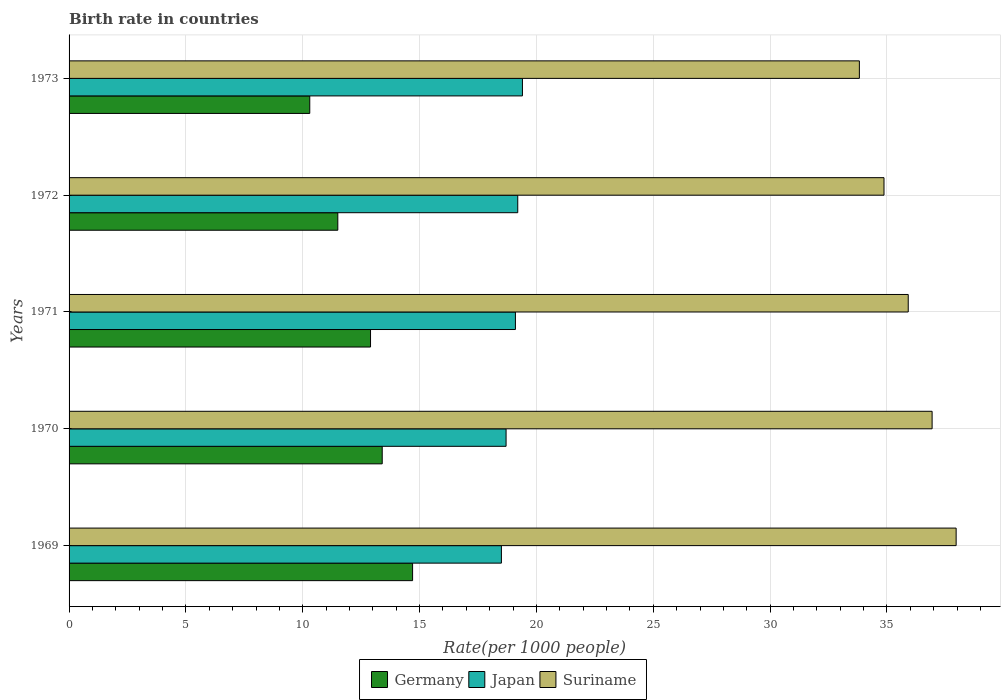How many bars are there on the 4th tick from the top?
Offer a very short reply. 3. What is the label of the 3rd group of bars from the top?
Keep it short and to the point. 1971. Across all years, what is the minimum birth rate in Germany?
Your answer should be very brief. 10.3. In which year was the birth rate in Germany maximum?
Your answer should be compact. 1969. In which year was the birth rate in Japan minimum?
Make the answer very short. 1969. What is the total birth rate in Japan in the graph?
Give a very brief answer. 94.9. What is the difference between the birth rate in Germany in 1971 and that in 1973?
Your answer should be very brief. 2.6. What is the difference between the birth rate in Suriname in 1970 and the birth rate in Germany in 1973?
Offer a very short reply. 26.63. What is the average birth rate in Suriname per year?
Your answer should be compact. 35.9. In the year 1970, what is the difference between the birth rate in Germany and birth rate in Suriname?
Give a very brief answer. -23.53. What is the ratio of the birth rate in Japan in 1970 to that in 1973?
Your response must be concise. 0.96. Is the difference between the birth rate in Germany in 1969 and 1971 greater than the difference between the birth rate in Suriname in 1969 and 1971?
Your response must be concise. No. What is the difference between the highest and the second highest birth rate in Suriname?
Your response must be concise. 1.03. What is the difference between the highest and the lowest birth rate in Suriname?
Ensure brevity in your answer.  4.14. In how many years, is the birth rate in Suriname greater than the average birth rate in Suriname taken over all years?
Offer a very short reply. 3. Is the sum of the birth rate in Japan in 1969 and 1972 greater than the maximum birth rate in Suriname across all years?
Give a very brief answer. No. What does the 2nd bar from the top in 1970 represents?
Ensure brevity in your answer.  Japan. What does the 3rd bar from the bottom in 1971 represents?
Ensure brevity in your answer.  Suriname. How many bars are there?
Offer a terse response. 15. What is the difference between two consecutive major ticks on the X-axis?
Your response must be concise. 5. Does the graph contain any zero values?
Your answer should be very brief. No. Does the graph contain grids?
Provide a short and direct response. Yes. What is the title of the graph?
Provide a short and direct response. Birth rate in countries. What is the label or title of the X-axis?
Ensure brevity in your answer.  Rate(per 1000 people). What is the label or title of the Y-axis?
Your answer should be very brief. Years. What is the Rate(per 1000 people) in Germany in 1969?
Provide a succinct answer. 14.7. What is the Rate(per 1000 people) of Japan in 1969?
Provide a short and direct response. 18.5. What is the Rate(per 1000 people) in Suriname in 1969?
Provide a short and direct response. 37.96. What is the Rate(per 1000 people) of Germany in 1970?
Your response must be concise. 13.4. What is the Rate(per 1000 people) of Japan in 1970?
Your response must be concise. 18.7. What is the Rate(per 1000 people) in Suriname in 1970?
Keep it short and to the point. 36.93. What is the Rate(per 1000 people) in Germany in 1971?
Provide a short and direct response. 12.9. What is the Rate(per 1000 people) in Japan in 1971?
Offer a terse response. 19.1. What is the Rate(per 1000 people) of Suriname in 1971?
Your answer should be compact. 35.91. What is the Rate(per 1000 people) of Japan in 1972?
Your response must be concise. 19.2. What is the Rate(per 1000 people) of Suriname in 1972?
Provide a short and direct response. 34.87. What is the Rate(per 1000 people) in Germany in 1973?
Provide a short and direct response. 10.3. What is the Rate(per 1000 people) of Suriname in 1973?
Keep it short and to the point. 33.82. Across all years, what is the maximum Rate(per 1000 people) of Germany?
Make the answer very short. 14.7. Across all years, what is the maximum Rate(per 1000 people) of Japan?
Your response must be concise. 19.4. Across all years, what is the maximum Rate(per 1000 people) in Suriname?
Your response must be concise. 37.96. Across all years, what is the minimum Rate(per 1000 people) of Germany?
Keep it short and to the point. 10.3. Across all years, what is the minimum Rate(per 1000 people) of Japan?
Your response must be concise. 18.5. Across all years, what is the minimum Rate(per 1000 people) of Suriname?
Provide a short and direct response. 33.82. What is the total Rate(per 1000 people) in Germany in the graph?
Your answer should be compact. 62.8. What is the total Rate(per 1000 people) in Japan in the graph?
Your answer should be very brief. 94.9. What is the total Rate(per 1000 people) of Suriname in the graph?
Your answer should be very brief. 179.49. What is the difference between the Rate(per 1000 people) of Germany in 1969 and that in 1970?
Ensure brevity in your answer.  1.3. What is the difference between the Rate(per 1000 people) of Japan in 1969 and that in 1970?
Provide a short and direct response. -0.2. What is the difference between the Rate(per 1000 people) of Suriname in 1969 and that in 1970?
Make the answer very short. 1.03. What is the difference between the Rate(per 1000 people) in Germany in 1969 and that in 1971?
Provide a short and direct response. 1.8. What is the difference between the Rate(per 1000 people) in Japan in 1969 and that in 1971?
Keep it short and to the point. -0.6. What is the difference between the Rate(per 1000 people) in Suriname in 1969 and that in 1971?
Provide a succinct answer. 2.05. What is the difference between the Rate(per 1000 people) of Germany in 1969 and that in 1972?
Offer a very short reply. 3.2. What is the difference between the Rate(per 1000 people) of Japan in 1969 and that in 1972?
Offer a very short reply. -0.7. What is the difference between the Rate(per 1000 people) in Suriname in 1969 and that in 1972?
Your response must be concise. 3.09. What is the difference between the Rate(per 1000 people) of Germany in 1969 and that in 1973?
Make the answer very short. 4.4. What is the difference between the Rate(per 1000 people) in Japan in 1969 and that in 1973?
Offer a very short reply. -0.9. What is the difference between the Rate(per 1000 people) of Suriname in 1969 and that in 1973?
Your response must be concise. 4.14. What is the difference between the Rate(per 1000 people) of Japan in 1970 and that in 1971?
Ensure brevity in your answer.  -0.4. What is the difference between the Rate(per 1000 people) in Suriname in 1970 and that in 1971?
Make the answer very short. 1.02. What is the difference between the Rate(per 1000 people) in Japan in 1970 and that in 1972?
Offer a very short reply. -0.5. What is the difference between the Rate(per 1000 people) of Suriname in 1970 and that in 1972?
Ensure brevity in your answer.  2.06. What is the difference between the Rate(per 1000 people) of Germany in 1970 and that in 1973?
Your answer should be compact. 3.1. What is the difference between the Rate(per 1000 people) in Suriname in 1970 and that in 1973?
Offer a terse response. 3.11. What is the difference between the Rate(per 1000 people) of Germany in 1971 and that in 1972?
Make the answer very short. 1.4. What is the difference between the Rate(per 1000 people) of Japan in 1971 and that in 1972?
Provide a short and direct response. -0.1. What is the difference between the Rate(per 1000 people) of Suriname in 1971 and that in 1972?
Offer a terse response. 1.04. What is the difference between the Rate(per 1000 people) in Suriname in 1971 and that in 1973?
Make the answer very short. 2.09. What is the difference between the Rate(per 1000 people) of Germany in 1972 and that in 1973?
Your answer should be very brief. 1.2. What is the difference between the Rate(per 1000 people) in Japan in 1972 and that in 1973?
Provide a short and direct response. -0.2. What is the difference between the Rate(per 1000 people) of Suriname in 1972 and that in 1973?
Provide a succinct answer. 1.05. What is the difference between the Rate(per 1000 people) of Germany in 1969 and the Rate(per 1000 people) of Suriname in 1970?
Offer a terse response. -22.23. What is the difference between the Rate(per 1000 people) in Japan in 1969 and the Rate(per 1000 people) in Suriname in 1970?
Offer a terse response. -18.43. What is the difference between the Rate(per 1000 people) of Germany in 1969 and the Rate(per 1000 people) of Suriname in 1971?
Keep it short and to the point. -21.21. What is the difference between the Rate(per 1000 people) in Japan in 1969 and the Rate(per 1000 people) in Suriname in 1971?
Provide a succinct answer. -17.41. What is the difference between the Rate(per 1000 people) in Germany in 1969 and the Rate(per 1000 people) in Japan in 1972?
Offer a terse response. -4.5. What is the difference between the Rate(per 1000 people) of Germany in 1969 and the Rate(per 1000 people) of Suriname in 1972?
Keep it short and to the point. -20.17. What is the difference between the Rate(per 1000 people) of Japan in 1969 and the Rate(per 1000 people) of Suriname in 1972?
Give a very brief answer. -16.37. What is the difference between the Rate(per 1000 people) in Germany in 1969 and the Rate(per 1000 people) in Japan in 1973?
Your answer should be very brief. -4.7. What is the difference between the Rate(per 1000 people) in Germany in 1969 and the Rate(per 1000 people) in Suriname in 1973?
Your answer should be very brief. -19.12. What is the difference between the Rate(per 1000 people) in Japan in 1969 and the Rate(per 1000 people) in Suriname in 1973?
Provide a short and direct response. -15.32. What is the difference between the Rate(per 1000 people) in Germany in 1970 and the Rate(per 1000 people) in Suriname in 1971?
Provide a short and direct response. -22.51. What is the difference between the Rate(per 1000 people) of Japan in 1970 and the Rate(per 1000 people) of Suriname in 1971?
Your answer should be compact. -17.21. What is the difference between the Rate(per 1000 people) of Germany in 1970 and the Rate(per 1000 people) of Japan in 1972?
Give a very brief answer. -5.8. What is the difference between the Rate(per 1000 people) in Germany in 1970 and the Rate(per 1000 people) in Suriname in 1972?
Keep it short and to the point. -21.47. What is the difference between the Rate(per 1000 people) in Japan in 1970 and the Rate(per 1000 people) in Suriname in 1972?
Offer a very short reply. -16.17. What is the difference between the Rate(per 1000 people) in Germany in 1970 and the Rate(per 1000 people) in Japan in 1973?
Your answer should be very brief. -6. What is the difference between the Rate(per 1000 people) in Germany in 1970 and the Rate(per 1000 people) in Suriname in 1973?
Give a very brief answer. -20.42. What is the difference between the Rate(per 1000 people) in Japan in 1970 and the Rate(per 1000 people) in Suriname in 1973?
Your answer should be compact. -15.12. What is the difference between the Rate(per 1000 people) in Germany in 1971 and the Rate(per 1000 people) in Japan in 1972?
Offer a very short reply. -6.3. What is the difference between the Rate(per 1000 people) in Germany in 1971 and the Rate(per 1000 people) in Suriname in 1972?
Offer a terse response. -21.97. What is the difference between the Rate(per 1000 people) of Japan in 1971 and the Rate(per 1000 people) of Suriname in 1972?
Keep it short and to the point. -15.77. What is the difference between the Rate(per 1000 people) of Germany in 1971 and the Rate(per 1000 people) of Suriname in 1973?
Ensure brevity in your answer.  -20.92. What is the difference between the Rate(per 1000 people) in Japan in 1971 and the Rate(per 1000 people) in Suriname in 1973?
Your answer should be compact. -14.72. What is the difference between the Rate(per 1000 people) of Germany in 1972 and the Rate(per 1000 people) of Japan in 1973?
Keep it short and to the point. -7.9. What is the difference between the Rate(per 1000 people) of Germany in 1972 and the Rate(per 1000 people) of Suriname in 1973?
Your response must be concise. -22.32. What is the difference between the Rate(per 1000 people) of Japan in 1972 and the Rate(per 1000 people) of Suriname in 1973?
Keep it short and to the point. -14.62. What is the average Rate(per 1000 people) in Germany per year?
Provide a short and direct response. 12.56. What is the average Rate(per 1000 people) in Japan per year?
Give a very brief answer. 18.98. What is the average Rate(per 1000 people) of Suriname per year?
Your answer should be compact. 35.9. In the year 1969, what is the difference between the Rate(per 1000 people) in Germany and Rate(per 1000 people) in Japan?
Your response must be concise. -3.8. In the year 1969, what is the difference between the Rate(per 1000 people) in Germany and Rate(per 1000 people) in Suriname?
Ensure brevity in your answer.  -23.26. In the year 1969, what is the difference between the Rate(per 1000 people) in Japan and Rate(per 1000 people) in Suriname?
Your answer should be compact. -19.46. In the year 1970, what is the difference between the Rate(per 1000 people) in Germany and Rate(per 1000 people) in Japan?
Make the answer very short. -5.3. In the year 1970, what is the difference between the Rate(per 1000 people) in Germany and Rate(per 1000 people) in Suriname?
Provide a short and direct response. -23.53. In the year 1970, what is the difference between the Rate(per 1000 people) in Japan and Rate(per 1000 people) in Suriname?
Offer a terse response. -18.23. In the year 1971, what is the difference between the Rate(per 1000 people) of Germany and Rate(per 1000 people) of Suriname?
Provide a short and direct response. -23.01. In the year 1971, what is the difference between the Rate(per 1000 people) of Japan and Rate(per 1000 people) of Suriname?
Make the answer very short. -16.81. In the year 1972, what is the difference between the Rate(per 1000 people) of Germany and Rate(per 1000 people) of Japan?
Make the answer very short. -7.7. In the year 1972, what is the difference between the Rate(per 1000 people) of Germany and Rate(per 1000 people) of Suriname?
Make the answer very short. -23.37. In the year 1972, what is the difference between the Rate(per 1000 people) of Japan and Rate(per 1000 people) of Suriname?
Ensure brevity in your answer.  -15.67. In the year 1973, what is the difference between the Rate(per 1000 people) of Germany and Rate(per 1000 people) of Suriname?
Your answer should be compact. -23.52. In the year 1973, what is the difference between the Rate(per 1000 people) of Japan and Rate(per 1000 people) of Suriname?
Your answer should be compact. -14.42. What is the ratio of the Rate(per 1000 people) of Germany in 1969 to that in 1970?
Give a very brief answer. 1.1. What is the ratio of the Rate(per 1000 people) of Japan in 1969 to that in 1970?
Offer a terse response. 0.99. What is the ratio of the Rate(per 1000 people) of Suriname in 1969 to that in 1970?
Offer a terse response. 1.03. What is the ratio of the Rate(per 1000 people) of Germany in 1969 to that in 1971?
Make the answer very short. 1.14. What is the ratio of the Rate(per 1000 people) in Japan in 1969 to that in 1971?
Your answer should be very brief. 0.97. What is the ratio of the Rate(per 1000 people) of Suriname in 1969 to that in 1971?
Your answer should be very brief. 1.06. What is the ratio of the Rate(per 1000 people) in Germany in 1969 to that in 1972?
Offer a very short reply. 1.28. What is the ratio of the Rate(per 1000 people) in Japan in 1969 to that in 1972?
Your answer should be compact. 0.96. What is the ratio of the Rate(per 1000 people) in Suriname in 1969 to that in 1972?
Give a very brief answer. 1.09. What is the ratio of the Rate(per 1000 people) in Germany in 1969 to that in 1973?
Ensure brevity in your answer.  1.43. What is the ratio of the Rate(per 1000 people) in Japan in 1969 to that in 1973?
Make the answer very short. 0.95. What is the ratio of the Rate(per 1000 people) in Suriname in 1969 to that in 1973?
Provide a succinct answer. 1.12. What is the ratio of the Rate(per 1000 people) of Germany in 1970 to that in 1971?
Offer a terse response. 1.04. What is the ratio of the Rate(per 1000 people) in Japan in 1970 to that in 1971?
Provide a short and direct response. 0.98. What is the ratio of the Rate(per 1000 people) of Suriname in 1970 to that in 1971?
Offer a terse response. 1.03. What is the ratio of the Rate(per 1000 people) in Germany in 1970 to that in 1972?
Ensure brevity in your answer.  1.17. What is the ratio of the Rate(per 1000 people) in Suriname in 1970 to that in 1972?
Provide a short and direct response. 1.06. What is the ratio of the Rate(per 1000 people) in Germany in 1970 to that in 1973?
Your answer should be very brief. 1.3. What is the ratio of the Rate(per 1000 people) in Japan in 1970 to that in 1973?
Your answer should be compact. 0.96. What is the ratio of the Rate(per 1000 people) in Suriname in 1970 to that in 1973?
Offer a very short reply. 1.09. What is the ratio of the Rate(per 1000 people) in Germany in 1971 to that in 1972?
Provide a short and direct response. 1.12. What is the ratio of the Rate(per 1000 people) in Suriname in 1971 to that in 1972?
Provide a succinct answer. 1.03. What is the ratio of the Rate(per 1000 people) in Germany in 1971 to that in 1973?
Your answer should be very brief. 1.25. What is the ratio of the Rate(per 1000 people) of Japan in 1971 to that in 1973?
Make the answer very short. 0.98. What is the ratio of the Rate(per 1000 people) of Suriname in 1971 to that in 1973?
Offer a terse response. 1.06. What is the ratio of the Rate(per 1000 people) of Germany in 1972 to that in 1973?
Your response must be concise. 1.12. What is the ratio of the Rate(per 1000 people) of Japan in 1972 to that in 1973?
Keep it short and to the point. 0.99. What is the ratio of the Rate(per 1000 people) in Suriname in 1972 to that in 1973?
Offer a terse response. 1.03. What is the difference between the highest and the second highest Rate(per 1000 people) in Germany?
Offer a very short reply. 1.3. What is the difference between the highest and the second highest Rate(per 1000 people) in Suriname?
Provide a short and direct response. 1.03. What is the difference between the highest and the lowest Rate(per 1000 people) in Germany?
Your answer should be very brief. 4.4. What is the difference between the highest and the lowest Rate(per 1000 people) in Japan?
Offer a terse response. 0.9. What is the difference between the highest and the lowest Rate(per 1000 people) of Suriname?
Your answer should be very brief. 4.14. 